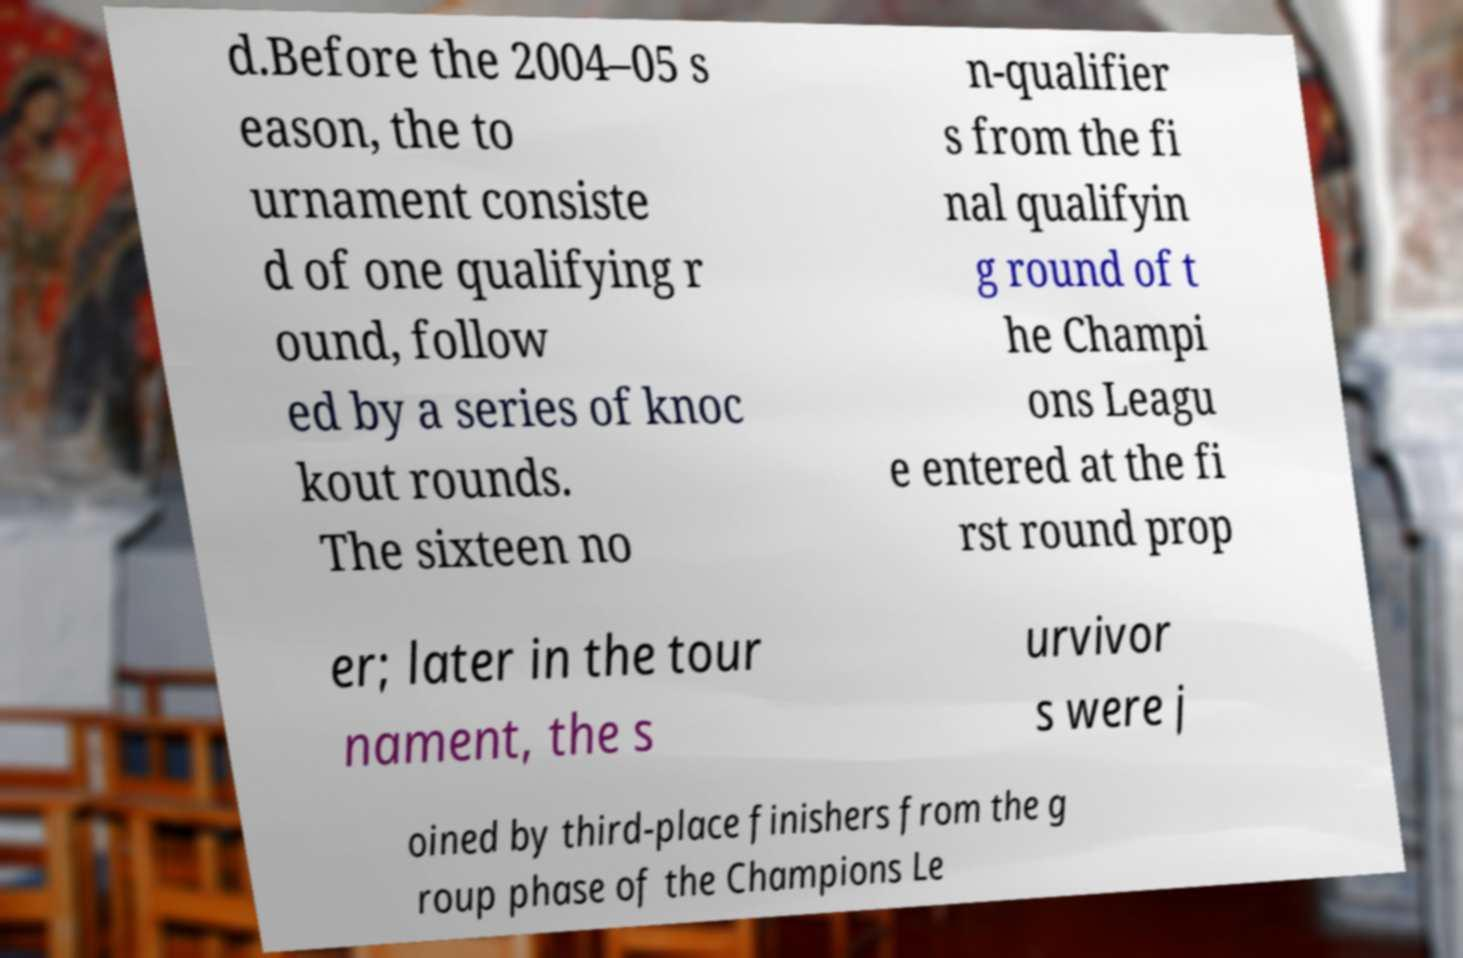Please read and relay the text visible in this image. What does it say? d.Before the 2004–05 s eason, the to urnament consiste d of one qualifying r ound, follow ed by a series of knoc kout rounds. The sixteen no n-qualifier s from the fi nal qualifyin g round of t he Champi ons Leagu e entered at the fi rst round prop er; later in the tour nament, the s urvivor s were j oined by third-place finishers from the g roup phase of the Champions Le 